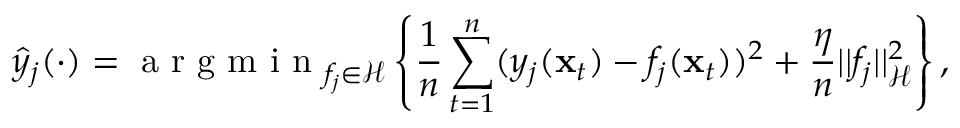Convert formula to latex. <formula><loc_0><loc_0><loc_500><loc_500>\hat { y } _ { j } ( \cdot ) = a r g m i n _ { f _ { j } \in \mathcal { H } } \left \{ \frac { 1 } { n } \sum _ { t = 1 } ^ { n } ( y _ { j } ( \mathbf x _ { t } ) - f _ { j } ( \mathbf x _ { t } ) ) ^ { 2 } + \frac { \eta } { n } | | f _ { j } | | _ { \mathcal { H } } ^ { 2 } \right \} ,</formula> 